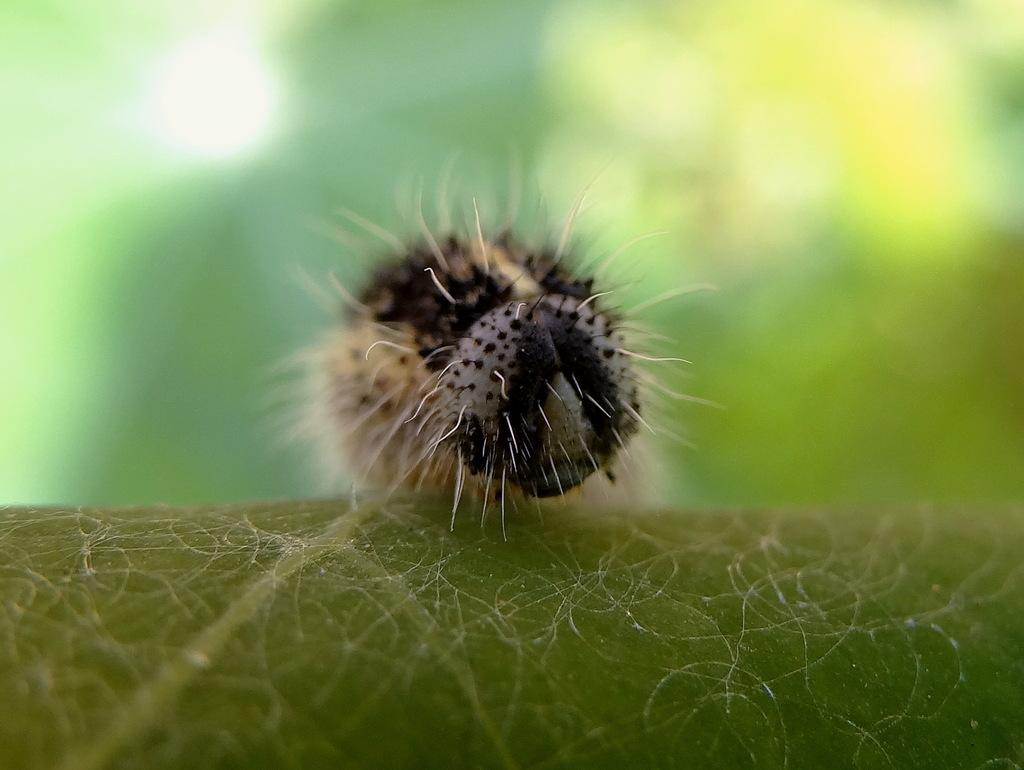What type of creature is present in the image? There is an insect in the image. Can you describe the background of the insect? The background of the insect is blurred. What type of legal advice is the lawyer providing to the dad in the image? There is no lawyer or dad present in the image; it only features an insect with a blurred background. 